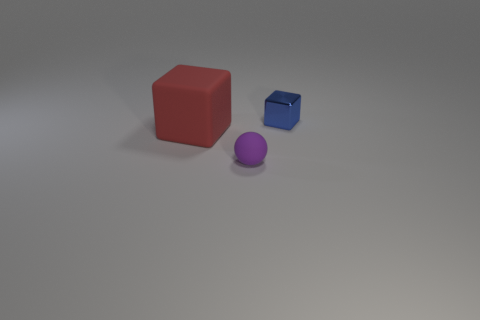There is another matte thing that is the same shape as the blue object; what is its size?
Offer a terse response. Large. Is the color of the tiny rubber ball the same as the big matte cube?
Provide a short and direct response. No. What color is the object that is both behind the small purple rubber object and left of the small blue shiny object?
Your answer should be compact. Red. How many objects are either rubber things to the left of the purple matte object or big metallic balls?
Your response must be concise. 1. What color is the other matte object that is the same shape as the small blue thing?
Offer a very short reply. Red. Do the small blue thing and the object in front of the large object have the same shape?
Your response must be concise. No. How many objects are objects to the left of the shiny object or things on the right side of the large rubber object?
Ensure brevity in your answer.  3. Are there fewer large blocks to the right of the purple thing than red matte blocks?
Your response must be concise. Yes. Does the tiny purple object have the same material as the thing that is behind the red cube?
Your response must be concise. No. What is the small blue block made of?
Offer a very short reply. Metal. 